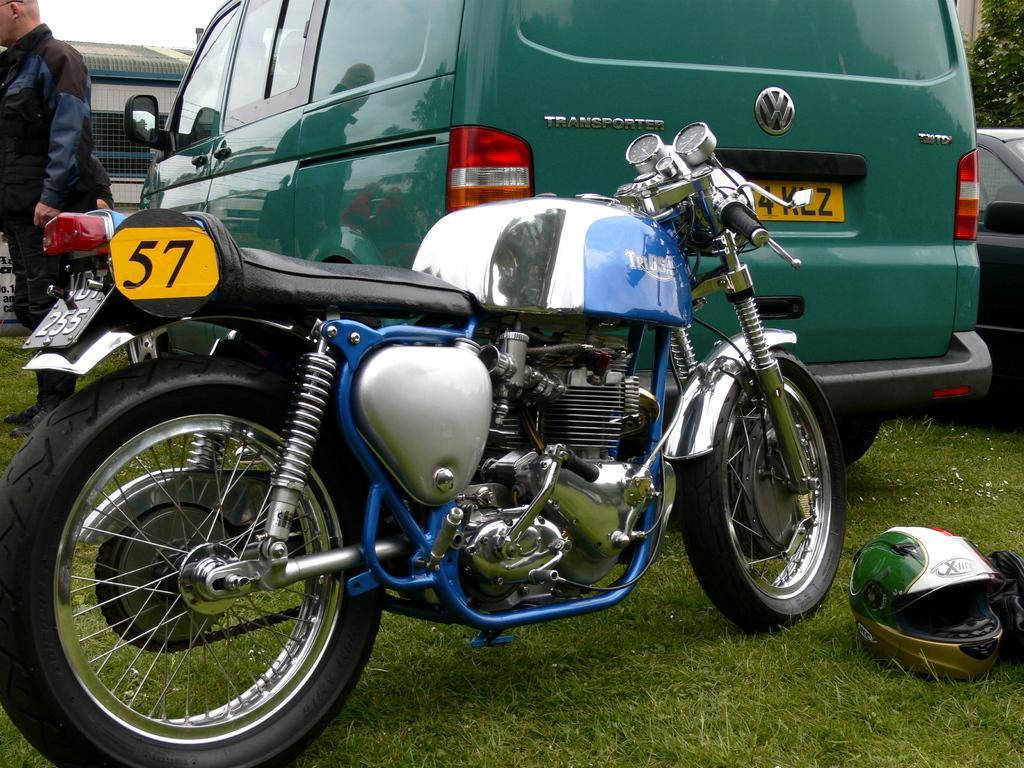In one or two sentences, can you explain what this image depicts? On the left side of the image we can see a person is standing. In the middle of the image we can see a bike on which a number is written and a car is there. On the right side of the image we can see a car, helmet and grass. 